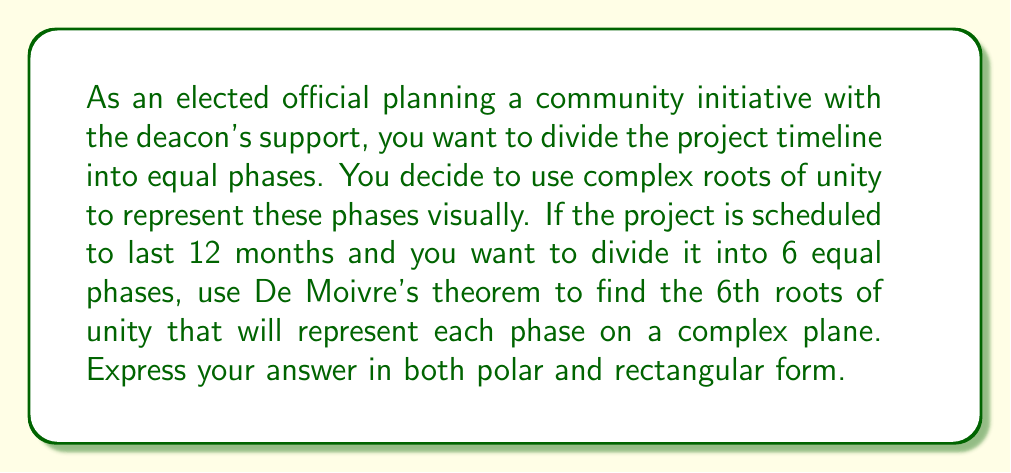Teach me how to tackle this problem. To solve this problem, we'll use De Moivre's theorem to find the nth roots of unity. In this case, n = 6.

1) The general formula for the kth nth root of unity is:

   $$z_k = e^{i(2\pi k/n)} = \cos(2\pi k/n) + i\sin(2\pi k/n)$$

   where k = 0, 1, 2, ..., n-1

2) For n = 6, we have:

   $$z_k = e^{i(2\pi k/6)} = \cos(2\pi k/6) + i\sin(2\pi k/6)$$

   where k = 0, 1, 2, 3, 4, 5

3) Let's calculate each root:

   For k = 0: $z_0 = e^{i(2\pi 0/6)} = \cos(0) + i\sin(0) = 1 + 0i = 1$

   For k = 1: $z_1 = e^{i(\pi/3)} = \cos(\pi/3) + i\sin(\pi/3) = \frac{1}{2} + i\frac{\sqrt{3}}{2}$

   For k = 2: $z_2 = e^{i(2\pi/3)} = \cos(2\pi/3) + i\sin(2\pi/3) = -\frac{1}{2} + i\frac{\sqrt{3}}{2}$

   For k = 3: $z_3 = e^{i\pi} = \cos(\pi) + i\sin(\pi) = -1 + 0i = -1$

   For k = 4: $z_4 = e^{i(4\pi/3)} = \cos(4\pi/3) + i\sin(4\pi/3) = -\frac{1}{2} - i\frac{\sqrt{3}}{2}$

   For k = 5: $z_5 = e^{i(5\pi/3)} = \cos(5\pi/3) + i\sin(5\pi/3) = \frac{1}{2} - i\frac{\sqrt{3}}{2}$

4) To express these in polar form, we use the formula $r(\cos\theta + i\sin\theta)$ where $r = 1$ for all roots of unity.

   $z_0 = 1(\cos 0 + i\sin 0)$
   $z_1 = 1(\cos \frac{\pi}{3} + i\sin \frac{\pi}{3})$
   $z_2 = 1(\cos \frac{2\pi}{3} + i\sin \frac{2\pi}{3})$
   $z_3 = 1(\cos \pi + i\sin \pi)$
   $z_4 = 1(\cos \frac{4\pi}{3} + i\sin \frac{4\pi}{3})$
   $z_5 = 1(\cos \frac{5\pi}{3} + i\sin \frac{5\pi}{3})$

These roots represent the 6 equal phases of your 12-month project on the complex plane.
Answer: The 6th roots of unity are:

In rectangular form:
$z_0 = 1$
$z_1 = \frac{1}{2} + i\frac{\sqrt{3}}{2}$
$z_2 = -\frac{1}{2} + i\frac{\sqrt{3}}{2}$
$z_3 = -1$
$z_4 = -\frac{1}{2} - i\frac{\sqrt{3}}{2}$
$z_5 = \frac{1}{2} - i\frac{\sqrt{3}}{2}$

In polar form:
$z_0 = 1(\cos 0 + i\sin 0)$
$z_1 = 1(\cos \frac{\pi}{3} + i\sin \frac{\pi}{3})$
$z_2 = 1(\cos \frac{2\pi}{3} + i\sin \frac{2\pi}{3})$
$z_3 = 1(\cos \pi + i\sin \pi)$
$z_4 = 1(\cos \frac{4\pi}{3} + i\sin \frac{4\pi}{3})$
$z_5 = 1(\cos \frac{5\pi}{3} + i\sin \frac{5\pi}{3})$ 